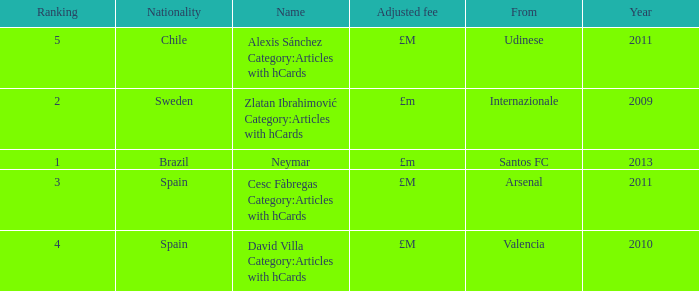Where is the ranked 2 players from? Internazionale. 